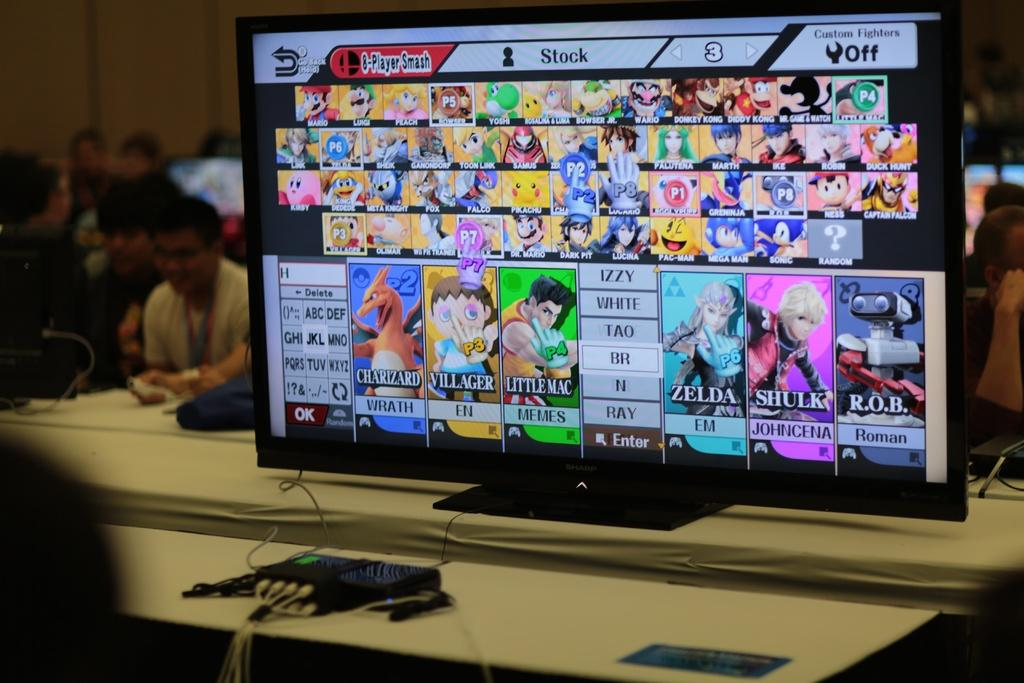<image>
Relay a brief, clear account of the picture shown. A monitor shows anime characters, including Charizard and Zelda. 